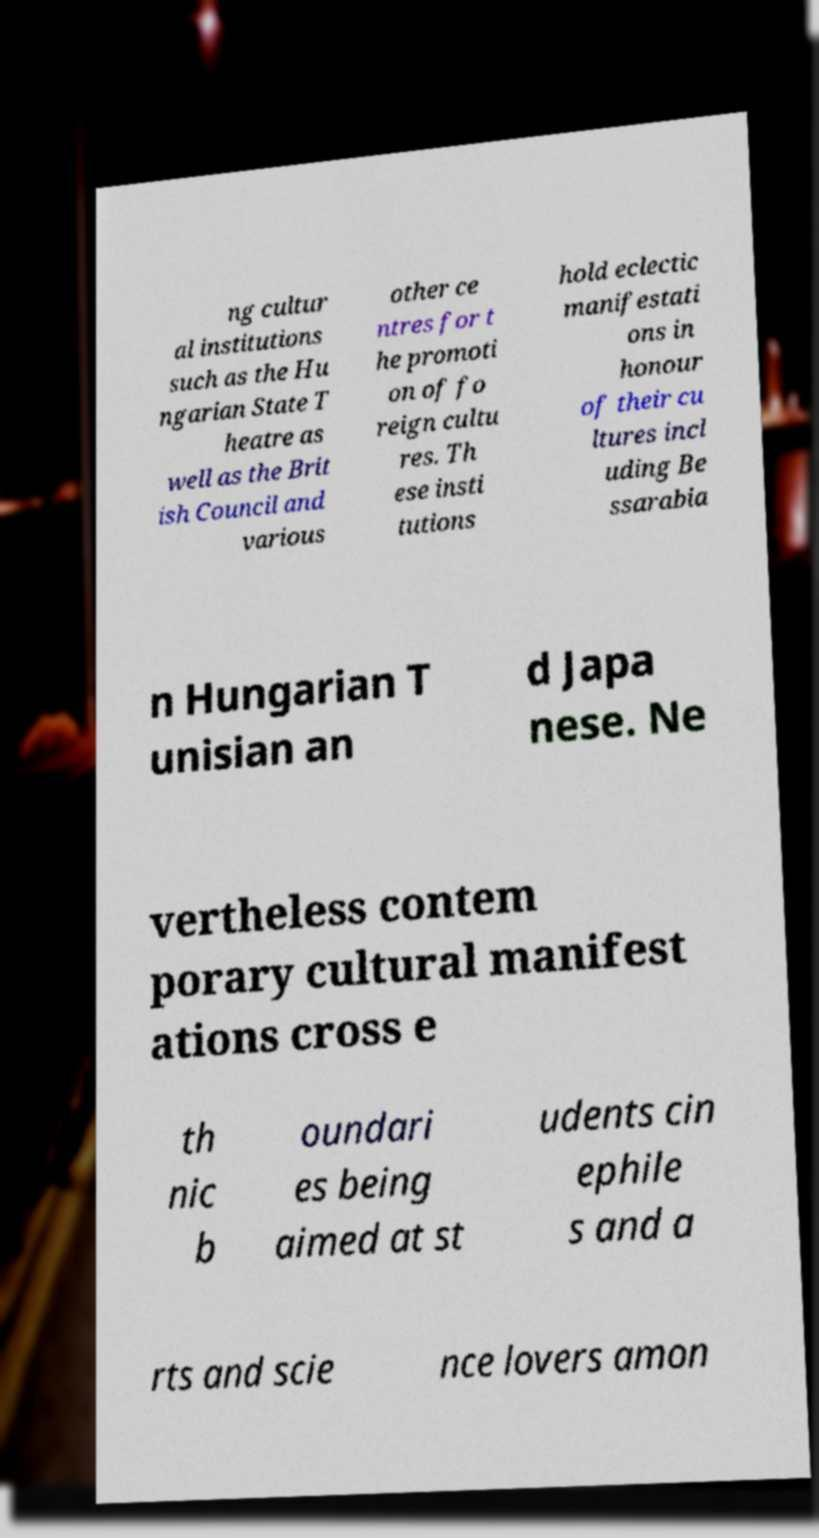What messages or text are displayed in this image? I need them in a readable, typed format. ng cultur al institutions such as the Hu ngarian State T heatre as well as the Brit ish Council and various other ce ntres for t he promoti on of fo reign cultu res. Th ese insti tutions hold eclectic manifestati ons in honour of their cu ltures incl uding Be ssarabia n Hungarian T unisian an d Japa nese. Ne vertheless contem porary cultural manifest ations cross e th nic b oundari es being aimed at st udents cin ephile s and a rts and scie nce lovers amon 